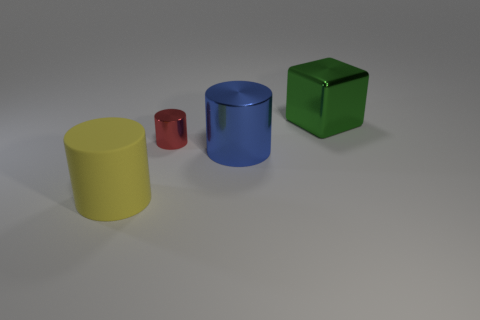There is a cylinder that is behind the big metallic thing to the left of the large thing to the right of the blue thing; how big is it?
Provide a short and direct response. Small. Does the large green cube have the same material as the large cylinder that is on the right side of the red thing?
Keep it short and to the point. Yes. Is the tiny red object the same shape as the big matte thing?
Provide a short and direct response. Yes. How many other objects are there of the same material as the red object?
Your answer should be very brief. 2. How many other big metal objects are the same shape as the red object?
Offer a terse response. 1. There is a big object that is both in front of the green thing and behind the yellow cylinder; what is its color?
Offer a very short reply. Blue. What number of red things are there?
Offer a very short reply. 1. Is the size of the blue metallic object the same as the metal cube?
Your answer should be very brief. Yes. Is there a tiny thing that has the same color as the big metal cylinder?
Give a very brief answer. No. Do the big shiny thing on the right side of the large blue metal thing and the red object have the same shape?
Provide a short and direct response. No. 